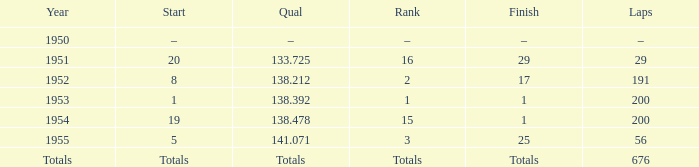How many laps were completed in the 13 191.0. 